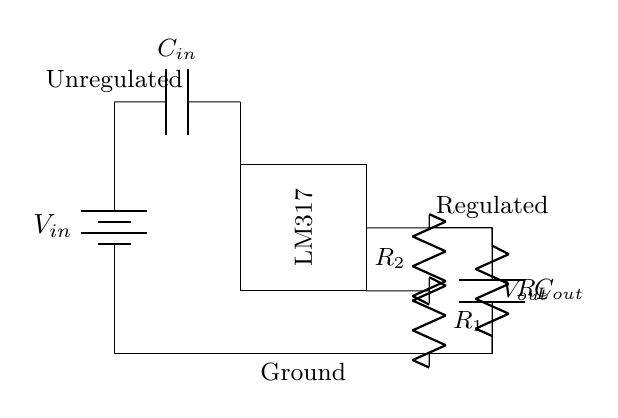What is the input voltage indicated in the circuit? The input voltage is represented by the battery symbol labeled as V_in at the left side of the diagram.
Answer: V_in What is the purpose of the LM317 in this circuit? The LM317 is a voltage regulator IC designed to maintain a stable output voltage, regardless of variations in the input voltage or load conditions.
Answer: Voltage regulator What components are used for filtering the input and output? There are an input capacitor labeled C_in and an output capacitor labeled C_out serving to filter the input and output of the regulator circuit.
Answer: C_in, C_out What is the role of resistors R1 and R2 in this circuit? Resistors R1 and R2 are adjustment resistors that set the output voltage level of the LM317 by forming a voltage divider configuration.
Answer: Adjustment Which part of the circuit indicates the regulated output voltage? The regulated output voltage is indicated by the line labeled V_out at the output side, coming from the LM317.
Answer: V_out How does the ground connection affect this circuit? The ground connection serves as a common reference point for all voltages in the circuit, stabilizing the operation of components like the LM317 and allowing for proper current flow.
Answer: Stabilizes operation 